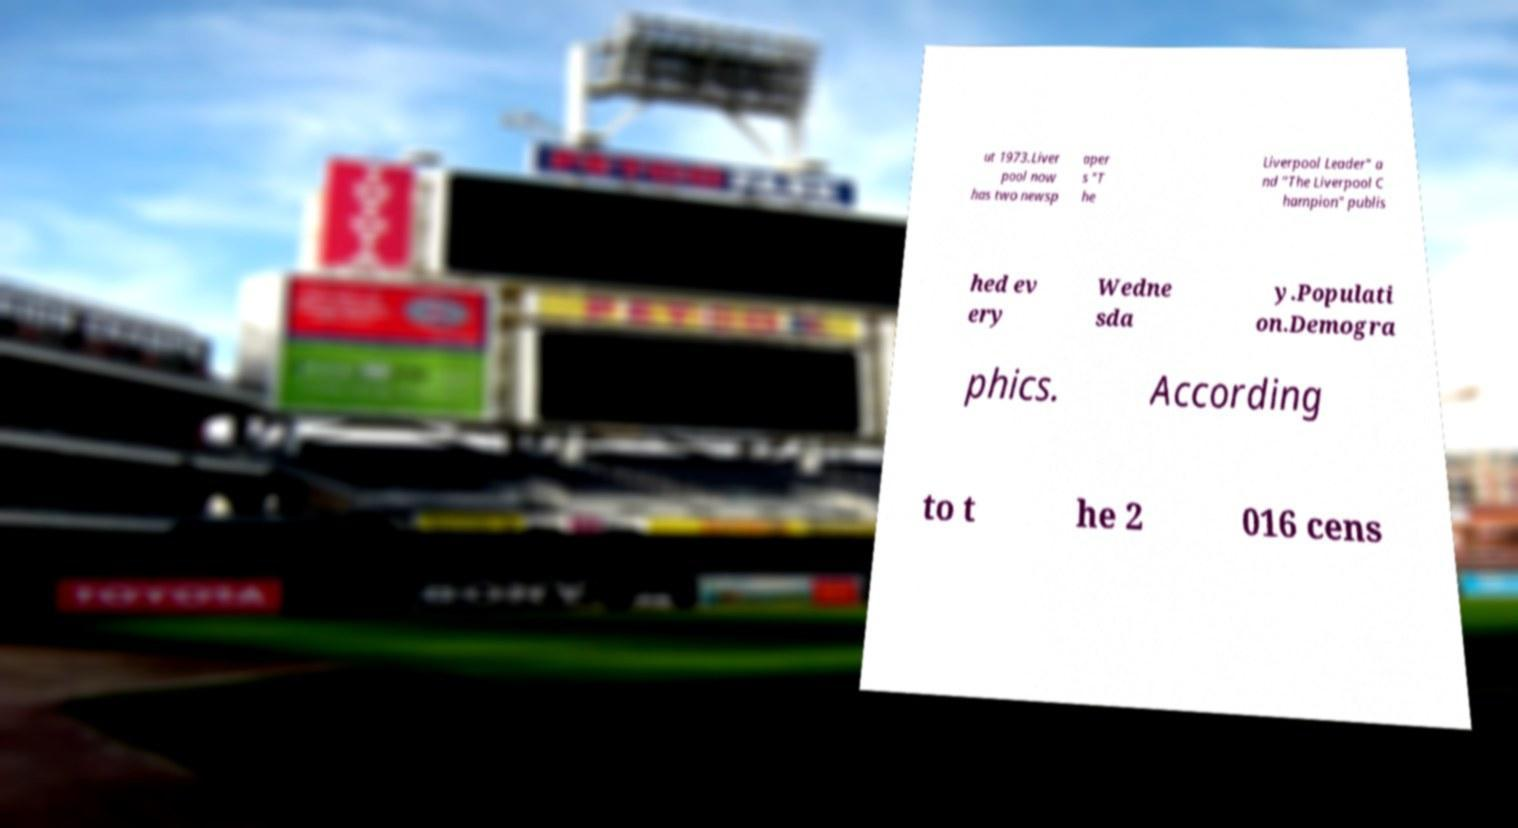There's text embedded in this image that I need extracted. Can you transcribe it verbatim? ut 1973.Liver pool now has two newsp aper s "T he Liverpool Leader" a nd "The Liverpool C hampion" publis hed ev ery Wedne sda y.Populati on.Demogra phics. According to t he 2 016 cens 